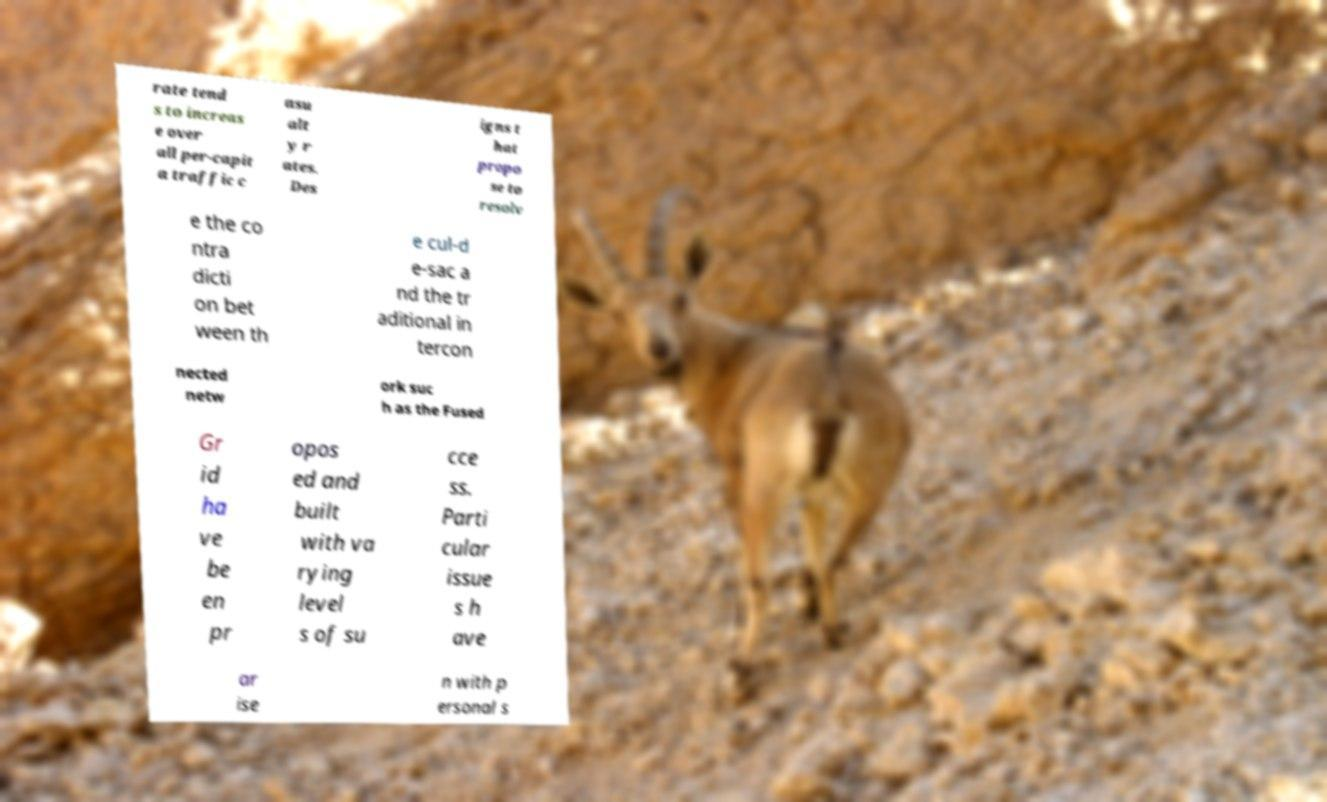Could you assist in decoding the text presented in this image and type it out clearly? rate tend s to increas e over all per-capit a traffic c asu alt y r ates. Des igns t hat propo se to resolv e the co ntra dicti on bet ween th e cul-d e-sac a nd the tr aditional in tercon nected netw ork suc h as the Fused Gr id ha ve be en pr opos ed and built with va rying level s of su cce ss. Parti cular issue s h ave ar ise n with p ersonal s 